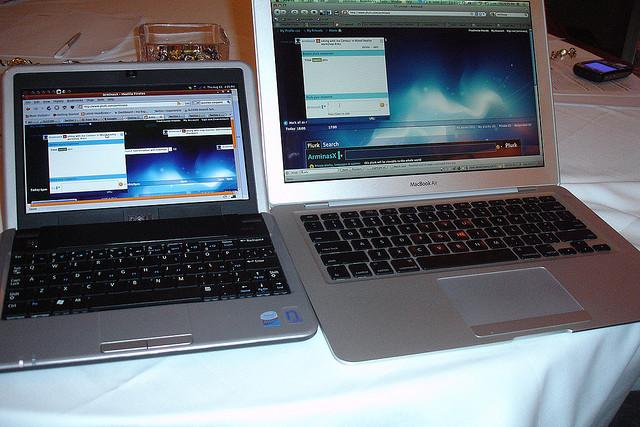What is side by side? laptops 